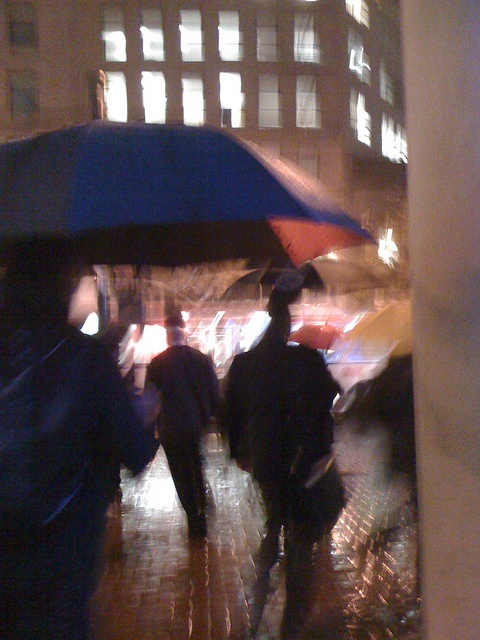Describe the objects in this image and their specific colors. I can see umbrella in brown, navy, black, and purple tones, people in brown, black, navy, and maroon tones, people in brown, black, maroon, and gray tones, people in brown, black, maroon, gray, and purple tones, and umbrella in brown, black, and maroon tones in this image. 